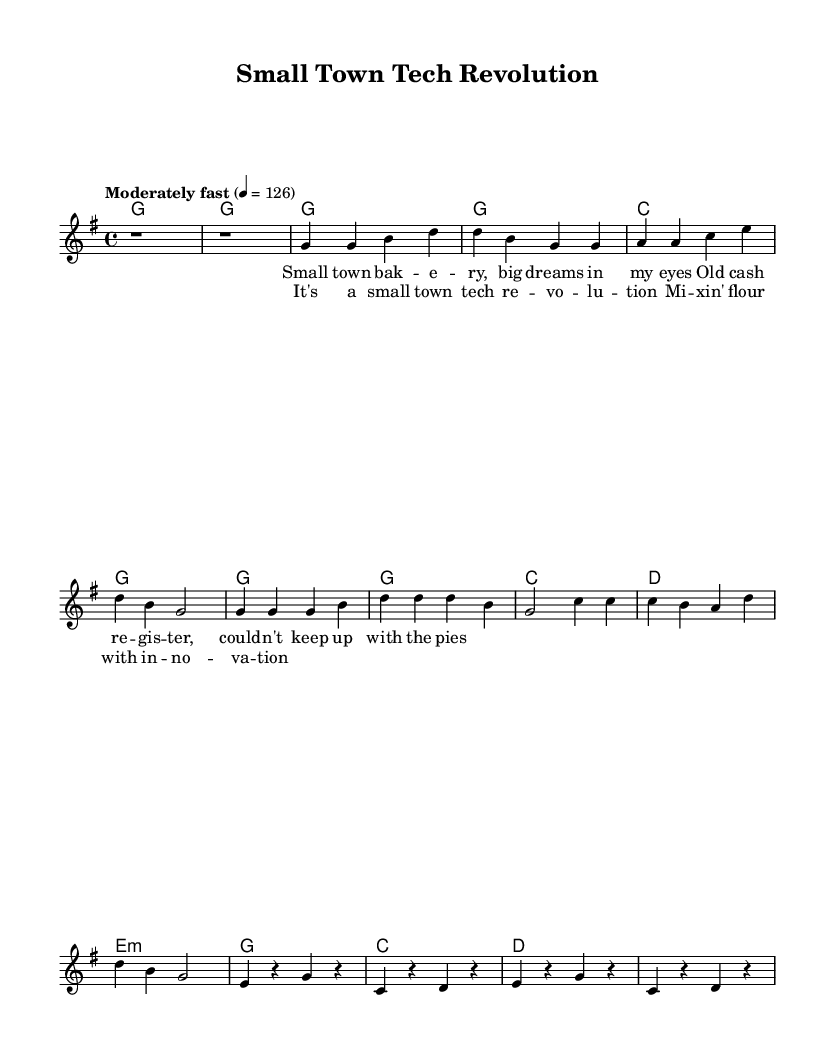What is the key signature of this music? The key signature is G major, which contains one sharp (F#). It is indicated at the beginning of the staff.
Answer: G major What is the time signature of this music? The time signature is 4/4, which means there are four beats per measure, and the quarter note gets one beat. This is denoted at the beginning of the sheet music.
Answer: 4/4 What is the tempo marking for this piece? The tempo marking is "Moderately fast," which typically indicates a speed around 120-140 beats per minute, specifically noted as the quarter note equals 126 beats per minute.
Answer: Moderately fast What is the main theme of the lyrics based on the title and context? The lyrics encapsulate innovation and success in a small-town bakery setting, as suggested by phrases about technology and baking.
Answer: Innovation Which chord is used in the bridge section? The bridge section uses several chords, specifically e minor, g major, c major, and d major as indicated in the chord progression.
Answer: e minor 